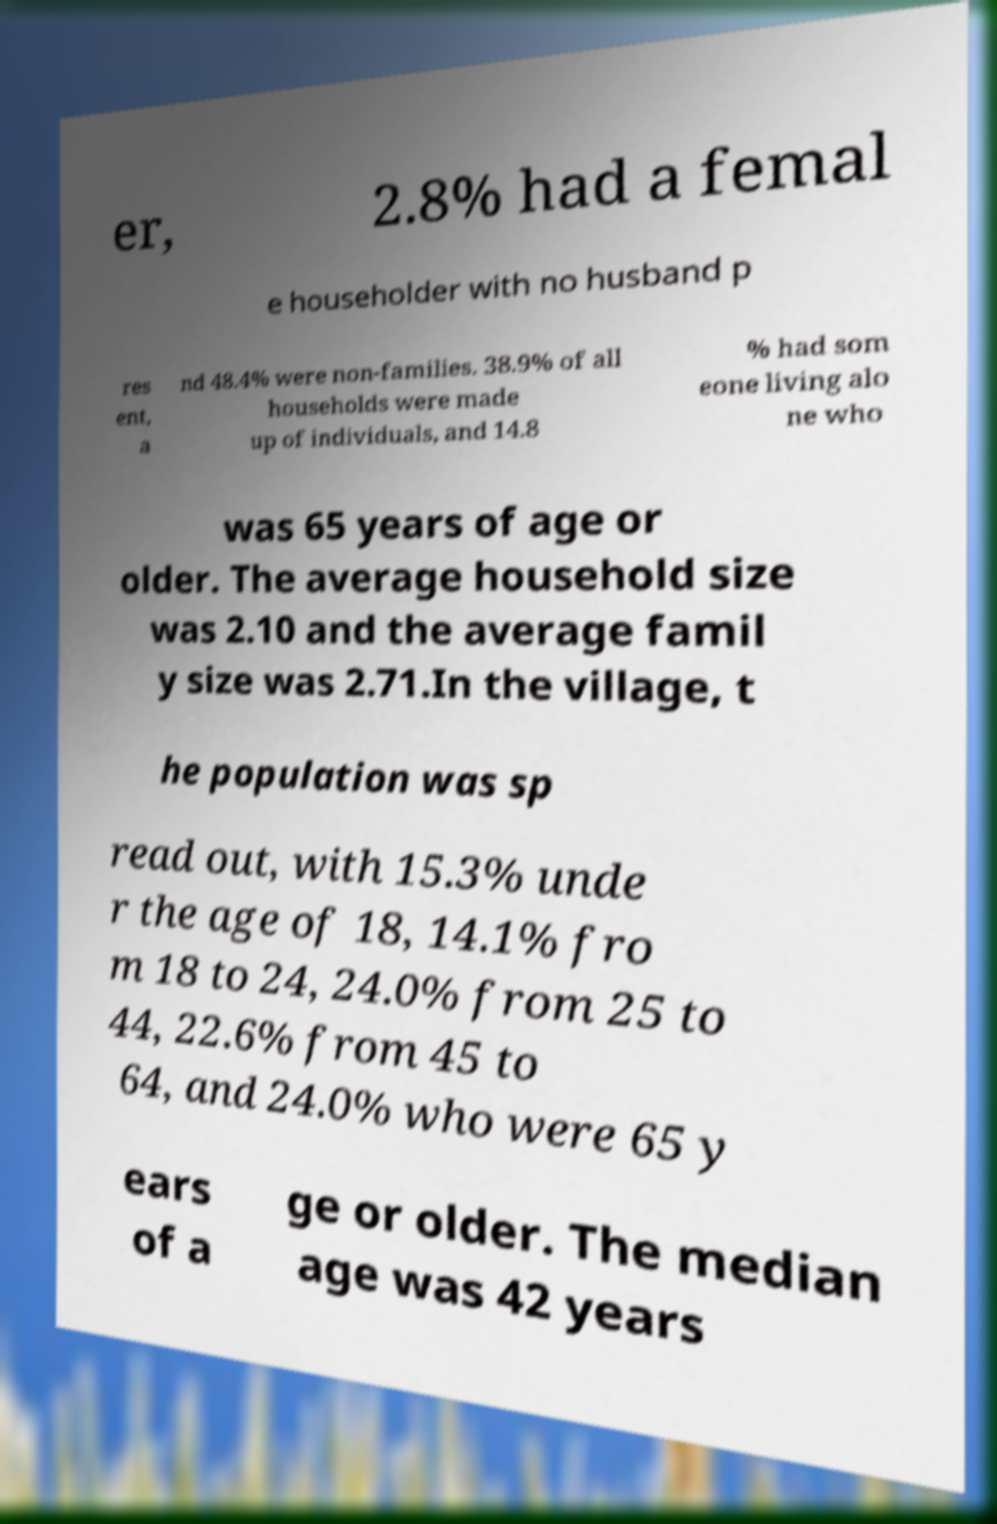Please identify and transcribe the text found in this image. er, 2.8% had a femal e householder with no husband p res ent, a nd 48.4% were non-families. 38.9% of all households were made up of individuals, and 14.8 % had som eone living alo ne who was 65 years of age or older. The average household size was 2.10 and the average famil y size was 2.71.In the village, t he population was sp read out, with 15.3% unde r the age of 18, 14.1% fro m 18 to 24, 24.0% from 25 to 44, 22.6% from 45 to 64, and 24.0% who were 65 y ears of a ge or older. The median age was 42 years 